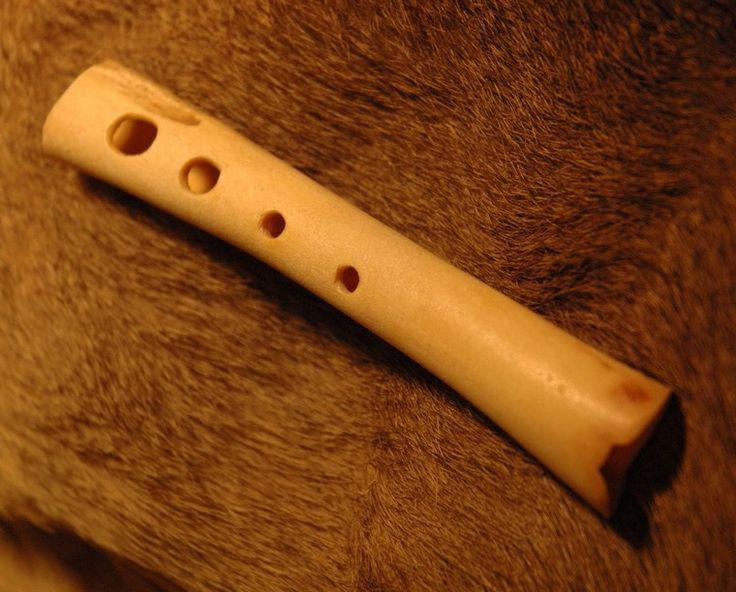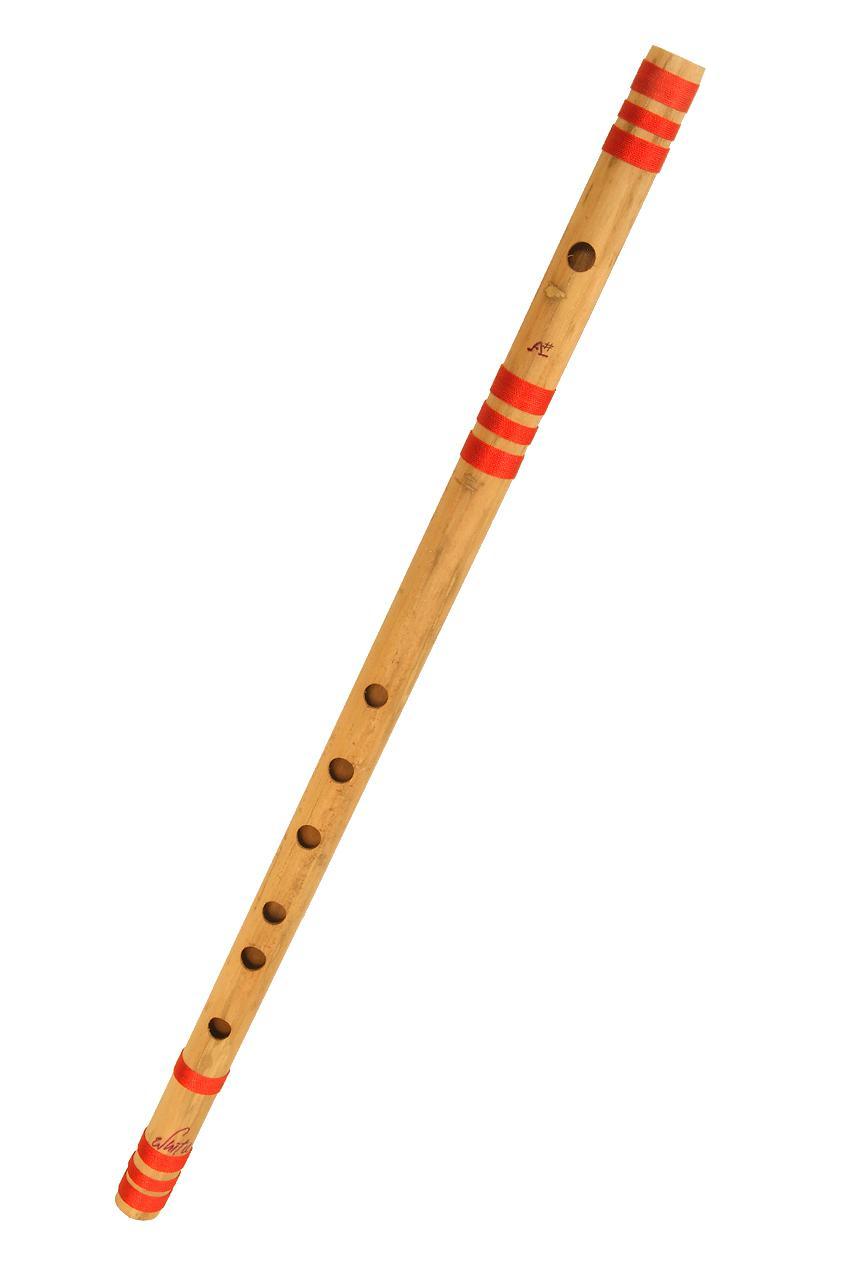The first image is the image on the left, the second image is the image on the right. Assess this claim about the two images: "There is one flute with red stripes and one flute without stripes.". Correct or not? Answer yes or no. Yes. 